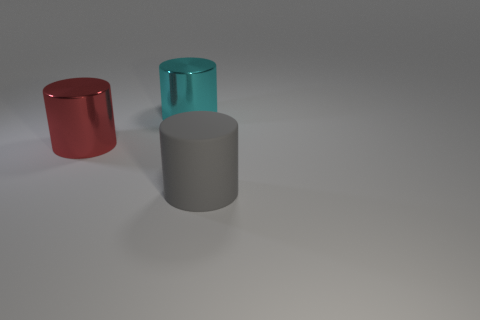Add 1 big purple matte things. How many objects exist? 4 Add 1 large cyan cylinders. How many large cyan cylinders exist? 2 Subtract 0 blue cylinders. How many objects are left? 3 Subtract all gray objects. Subtract all large red shiny cylinders. How many objects are left? 1 Add 2 cylinders. How many cylinders are left? 5 